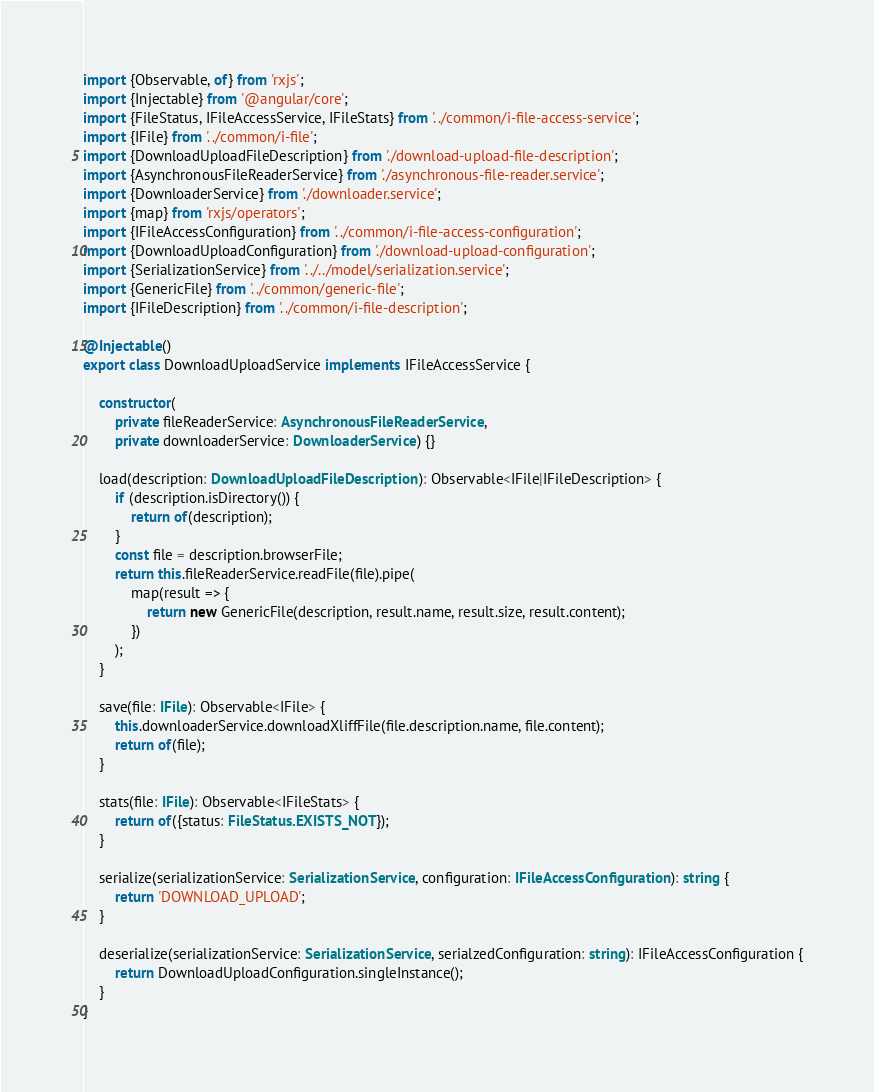<code> <loc_0><loc_0><loc_500><loc_500><_TypeScript_>import {Observable, of} from 'rxjs';
import {Injectable} from '@angular/core';
import {FileStatus, IFileAccessService, IFileStats} from '../common/i-file-access-service';
import {IFile} from '../common/i-file';
import {DownloadUploadFileDescription} from './download-upload-file-description';
import {AsynchronousFileReaderService} from './asynchronous-file-reader.service';
import {DownloaderService} from './downloader.service';
import {map} from 'rxjs/operators';
import {IFileAccessConfiguration} from '../common/i-file-access-configuration';
import {DownloadUploadConfiguration} from './download-upload-configuration';
import {SerializationService} from '../../model/serialization.service';
import {GenericFile} from '../common/generic-file';
import {IFileDescription} from '../common/i-file-description';

@Injectable()
export class DownloadUploadService implements IFileAccessService {

    constructor(
        private fileReaderService: AsynchronousFileReaderService,
        private downloaderService: DownloaderService) {}

    load(description: DownloadUploadFileDescription): Observable<IFile|IFileDescription> {
        if (description.isDirectory()) {
            return of(description);
        }
        const file = description.browserFile;
        return this.fileReaderService.readFile(file).pipe(
            map(result => {
                return new GenericFile(description, result.name, result.size, result.content);
            })
        );
    }

    save(file: IFile): Observable<IFile> {
        this.downloaderService.downloadXliffFile(file.description.name, file.content);
        return of(file);
    }

    stats(file: IFile): Observable<IFileStats> {
        return of({status: FileStatus.EXISTS_NOT});
    }

    serialize(serializationService: SerializationService, configuration: IFileAccessConfiguration): string {
        return 'DOWNLOAD_UPLOAD';
    }

    deserialize(serializationService: SerializationService, serialzedConfiguration: string): IFileAccessConfiguration {
        return DownloadUploadConfiguration.singleInstance();
    }
}
</code> 